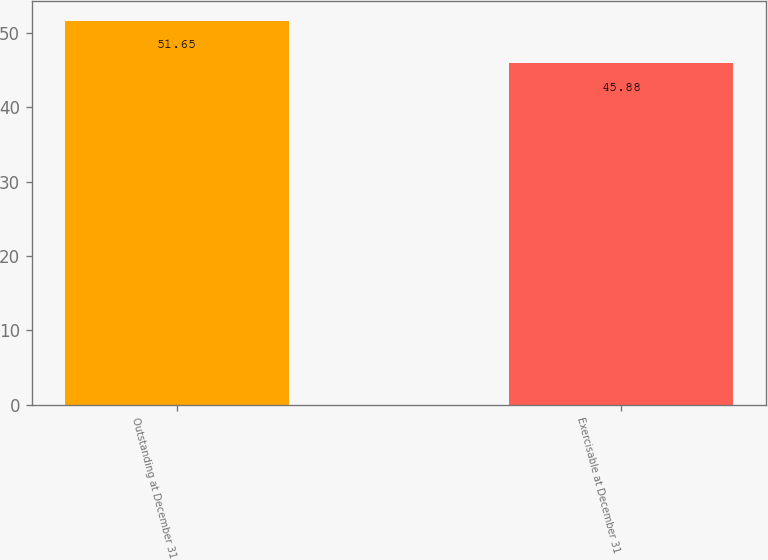<chart> <loc_0><loc_0><loc_500><loc_500><bar_chart><fcel>Outstanding at December 31<fcel>Exercisable at December 31<nl><fcel>51.65<fcel>45.88<nl></chart> 